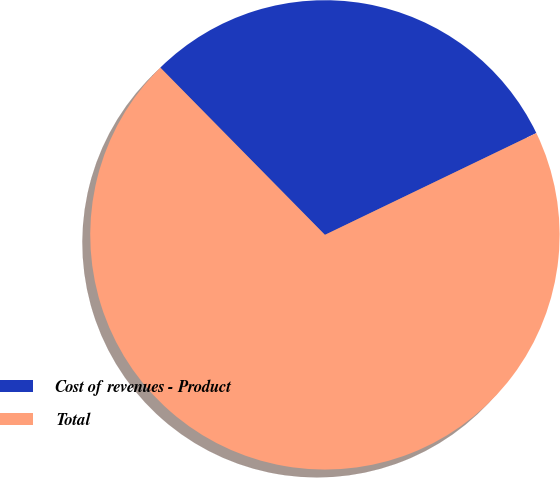<chart> <loc_0><loc_0><loc_500><loc_500><pie_chart><fcel>Cost of revenues - Product<fcel>Total<nl><fcel>30.23%<fcel>69.77%<nl></chart> 